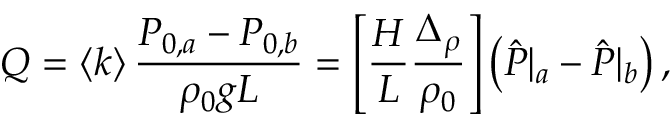Convert formula to latex. <formula><loc_0><loc_0><loc_500><loc_500>Q = \left < k \right > \frac { P _ { 0 , a } - P _ { 0 , b } } { \rho _ { 0 } g L } = \left [ \frac { H } { L } \frac { \Delta _ { \rho } } { \rho _ { 0 } } \right ] \left ( \hat { P } | _ { a } - \hat { P } | _ { b } \right ) ,</formula> 